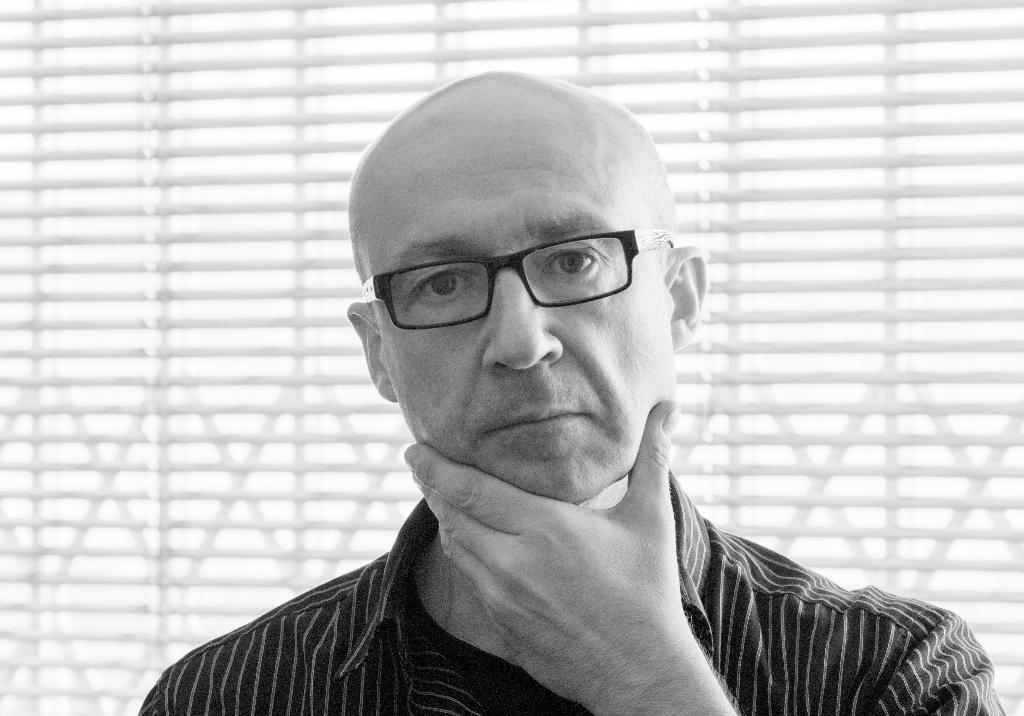Who is present in the image? There is a man in the picture. What is the man wearing in the image? The man is wearing spectacles. What is the color scheme of the image? The picture is black and white. What is the chance of the man's knee being affected by a zephyr in the image? There is no mention of a knee or a zephyr in the image, so it is not possible to determine the chance of any interaction between them. 